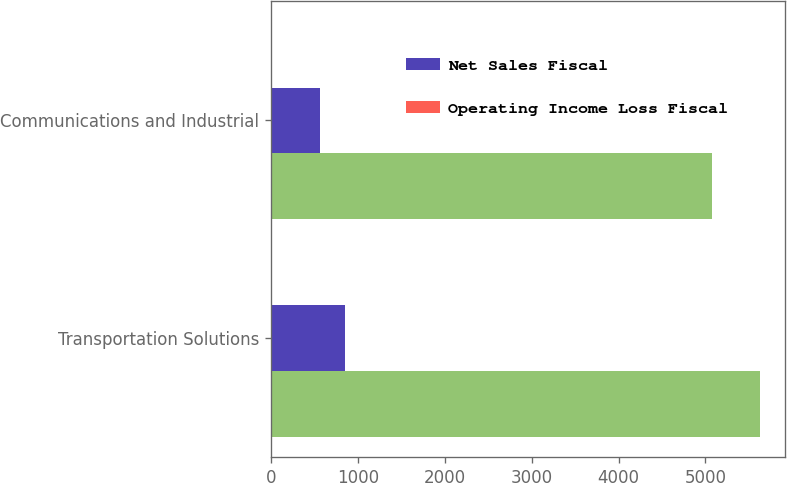Convert chart. <chart><loc_0><loc_0><loc_500><loc_500><stacked_bar_chart><ecel><fcel>Transportation Solutions<fcel>Communications and Industrial<nl><fcel>nan<fcel>5629<fcel>5071<nl><fcel>Net Sales Fiscal<fcel>848<fcel>564<nl><fcel>Operating Income Loss Fiscal<fcel>1<fcel>1<nl></chart> 